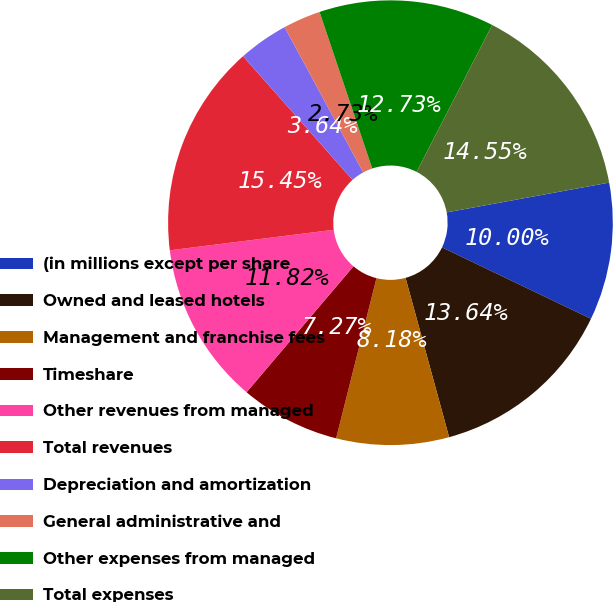Convert chart to OTSL. <chart><loc_0><loc_0><loc_500><loc_500><pie_chart><fcel>(in millions except per share<fcel>Owned and leased hotels<fcel>Management and franchise fees<fcel>Timeshare<fcel>Other revenues from managed<fcel>Total revenues<fcel>Depreciation and amortization<fcel>General administrative and<fcel>Other expenses from managed<fcel>Total expenses<nl><fcel>10.0%<fcel>13.64%<fcel>8.18%<fcel>7.27%<fcel>11.82%<fcel>15.45%<fcel>3.64%<fcel>2.73%<fcel>12.73%<fcel>14.55%<nl></chart> 